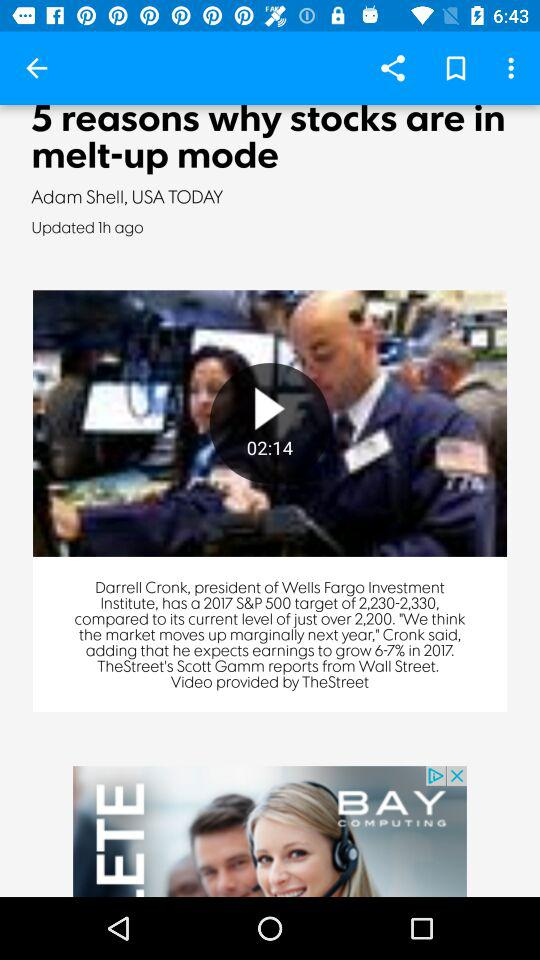What is the newspaper name? The newspaper name is "USA TODAY". 